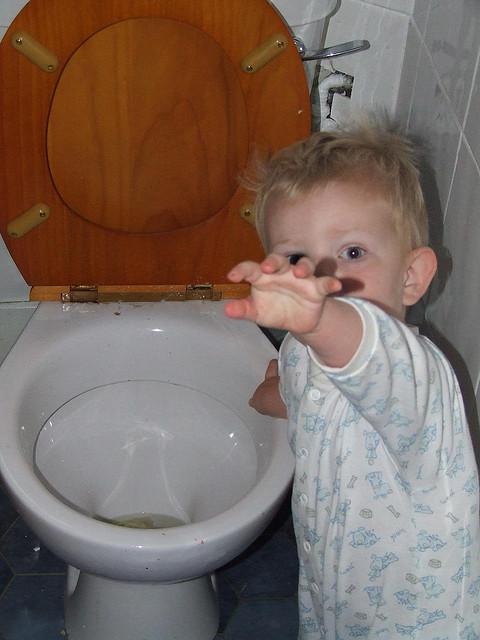Is the boy using the toilet?
Short answer required. No. What room is this?
Short answer required. Bathroom. What kind of toilet seat is that?
Be succinct. Wood. 